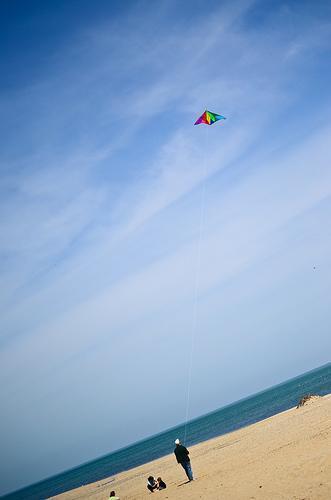How many people are in the picture?
Give a very brief answer. 1. 